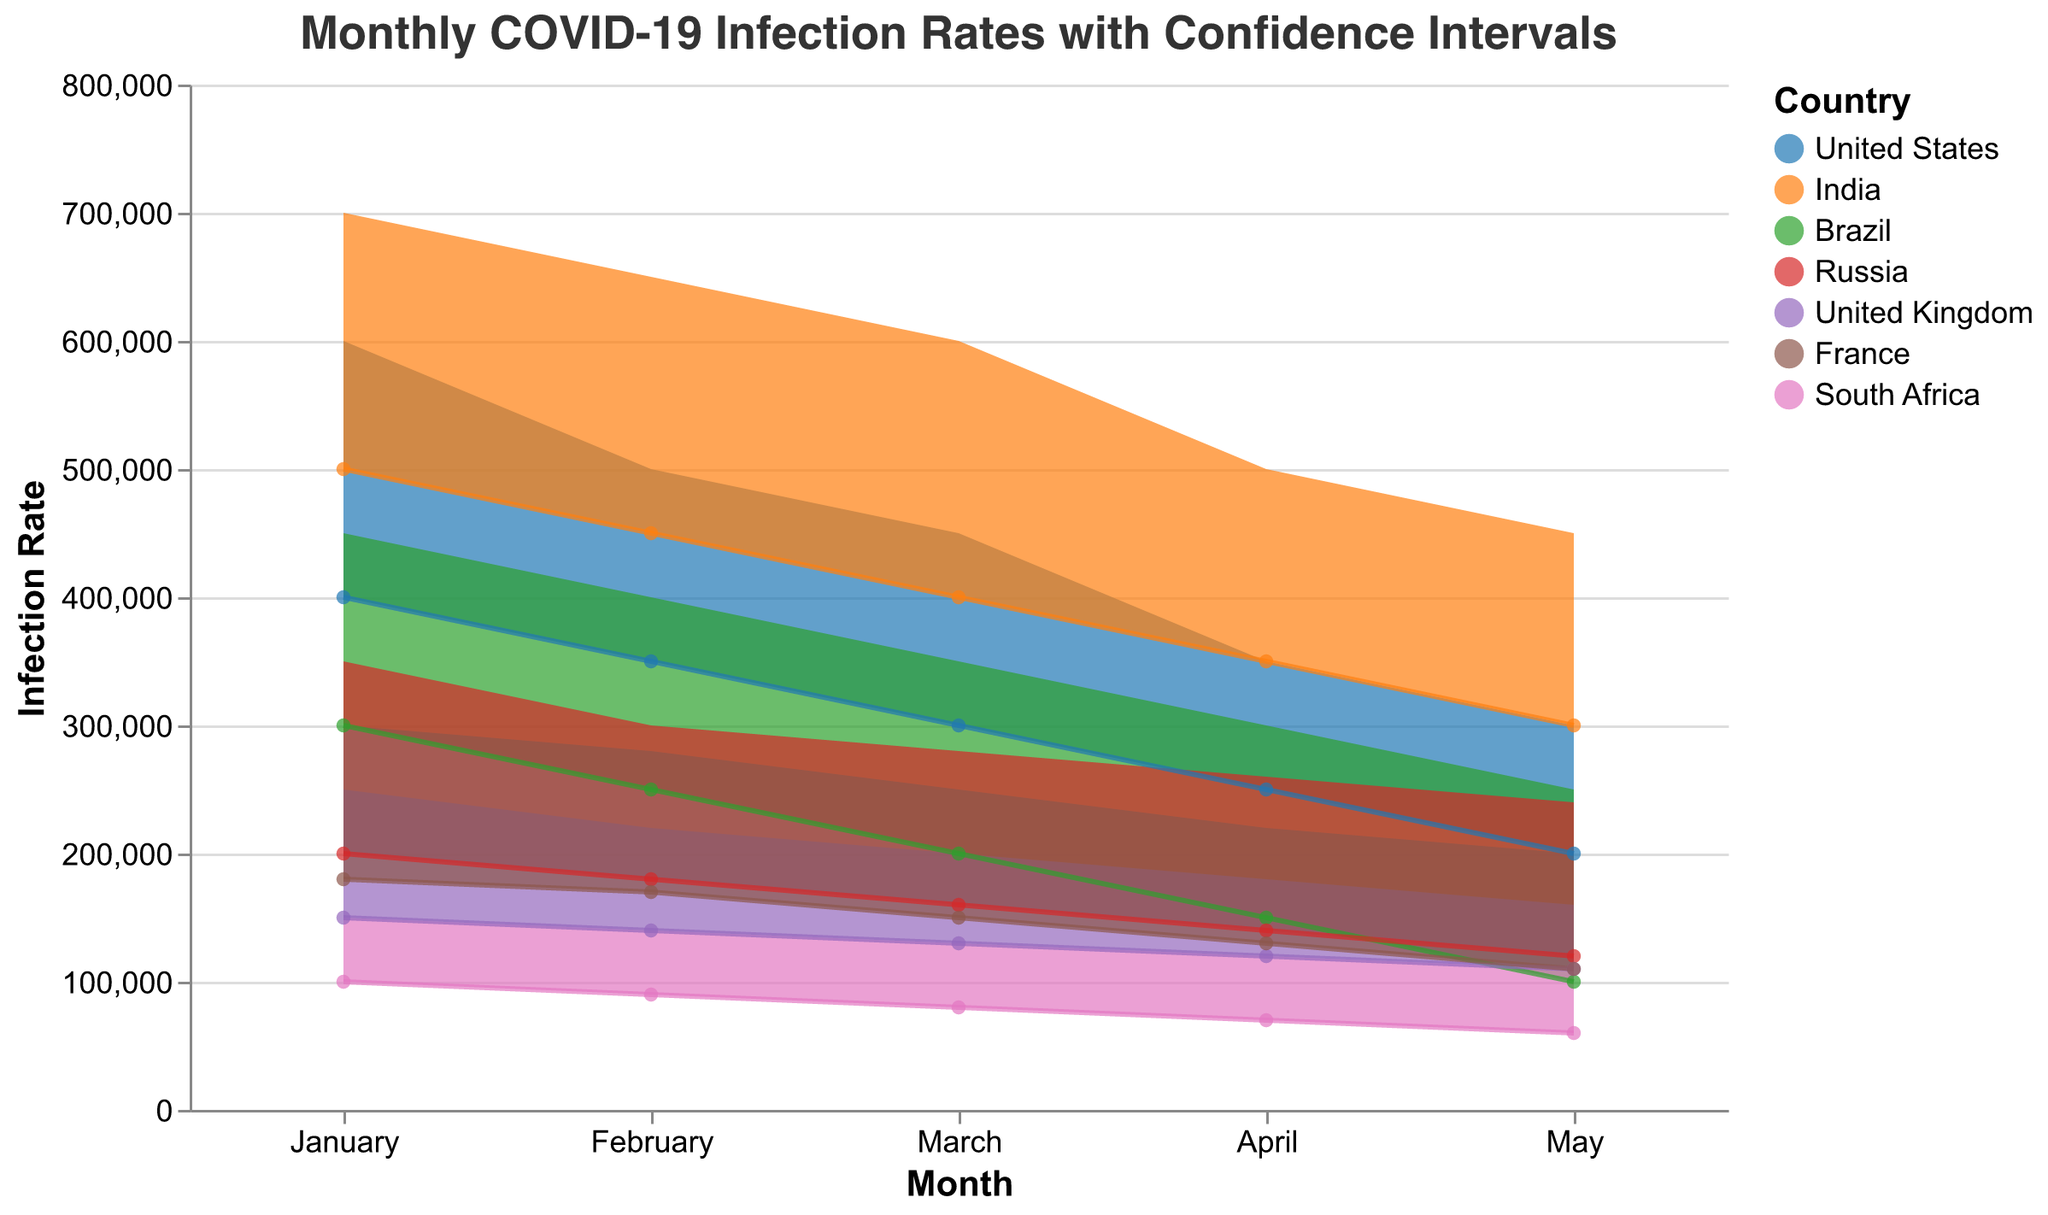What is the title of the chart? The title is displayed at the top of the chart in a larger font size. It reads "Monthly COVID-19 Infection Rates with Confidence Intervals."
Answer: Monthly COVID-19 Infection Rates with Confidence Intervals Which country had the highest maximum infection rate in January? By looking at the upper boundary of the shaded area for each country in January, we can see that India had the highest maximum infection rate with 700,000.
Answer: India How did the min infection rate of the United Kingdom change from January to May? We see from the bottom boundary of the shaded area for the United Kingdom that the min infection rate decreased from 150,000 in January to 110,000 in May.
Answer: It decreased Calculate the average maximum infection rate for Brazil from January to May. The maximum infection rates for Brazil from January to May are 450,000, 400,000, 350,000, 300,000, and 250,000 respectively. Adding these values: 450,000 + 400,000 + 350,000 + 300,000 + 250,000 = 1,750,000. Dividing by 5 gives us the average: 1,750,000 / 5 = 350,000.
Answer: 350,000 Which country experienced the greatest reduction in maximum infection rates from January to May? By observing the difference between the maximum infection rates in January and those in May for each country, we find that India had the greatest reduction, going from 700,000 to 450,000, a decrease of 250,000.
Answer: India How does the maximum infection rate for Russia in February compare to the United States in the same month? In February, Russia's maximum infection rate is 300,000 while the United States’ is 500,000. Thus, Russia's maximum infection rate is less than that of the United States.
Answer: Russia's is less What is the range of infection rates for South Africa in April? The range is determined by subtracting the minimum infection rate from the maximum infection rate for South Africa in April: 120,000 (max) - 70,000 (min) = 50,000.
Answer: 50,000 Compare the trend of infection rates for France and Brazil from March to May. Observing the shaded areas for France and Brazil from March to May, both countries show a downward trend in infection rates, but Brazil's decrease is steeper than France’s.
Answer: Both downward, Brazil is steeper What is the median minimum infection rate for France over the given months? The minimum infection rates for France over the months are: 180,000, 170,000, 150,000, 130,000, 110,000. Arranging these rates in ascending order: 110,000, 130,000, 150,000, 170,000, 180,000, the median value is the middle number: 150,000.
Answer: 150,000 Which month had the smallest range of infection rates for India? Calculating the range for each month for India: January (700,000-500,000=200,000), February (650,000-450,000=200,000), March (600,000-400,000=200,000), April (500,000-350,000=150,000), May (450,000-300,000=150,000). Both April and May have the smallest range of 150,000.
Answer: April and May 